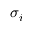<formula> <loc_0><loc_0><loc_500><loc_500>\sigma _ { i }</formula> 